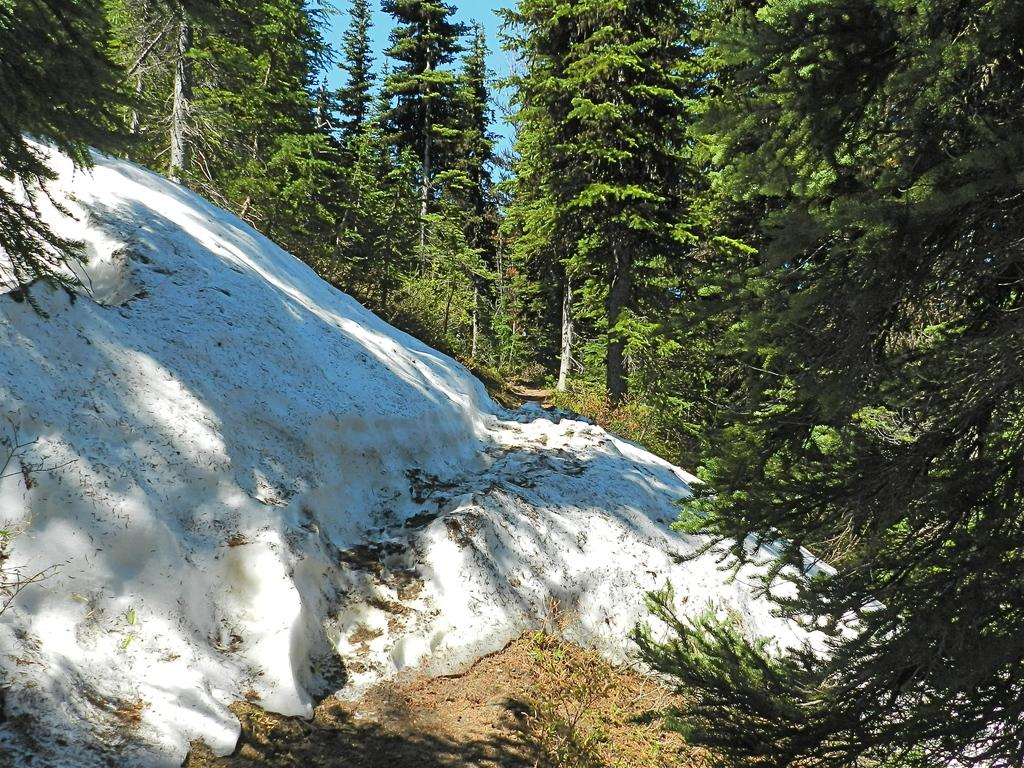What type of natural environment is depicted in the image? The image appears to be taken in a forest, as there are many trees visible. Can you describe any specific features of the trees in the image? The provided facts do not mention any specific features of the trees. What is the condition of the ground in the image? The presence of a rock covered with snow in the front of the image suggests that the ground is covered with snow. What type of wood is being used for writing in the image? There is no wood or writing present in the image; it depicts a forest with a rock covered with snow. 